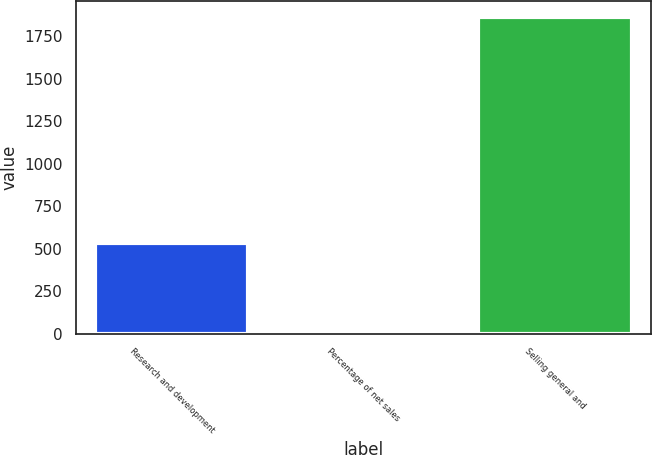Convert chart to OTSL. <chart><loc_0><loc_0><loc_500><loc_500><bar_chart><fcel>Research and development<fcel>Percentage of net sales<fcel>Selling general and<nl><fcel>535<fcel>4<fcel>1864<nl></chart> 